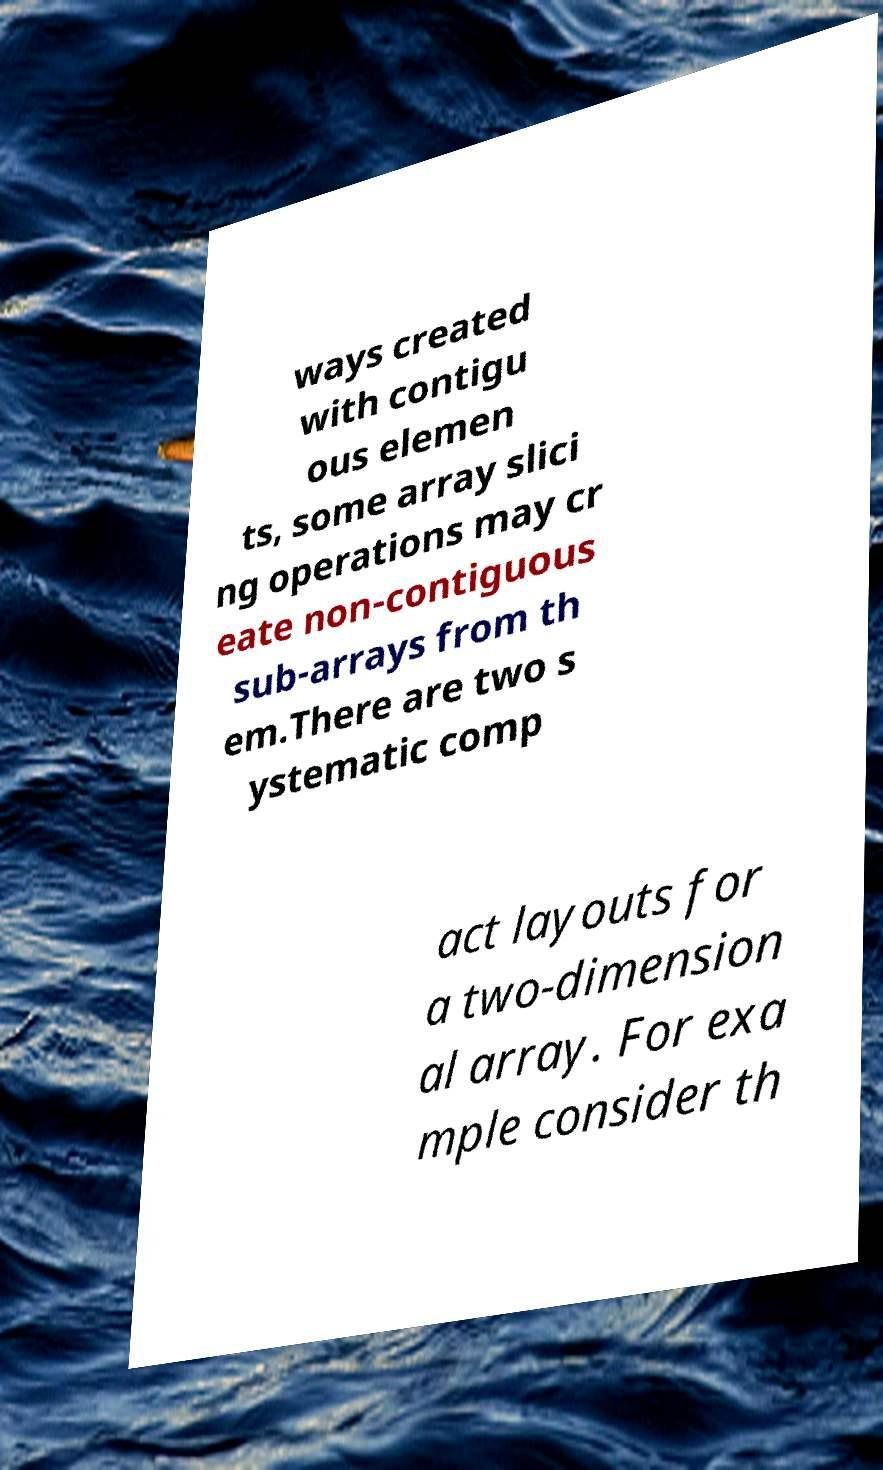There's text embedded in this image that I need extracted. Can you transcribe it verbatim? ways created with contigu ous elemen ts, some array slici ng operations may cr eate non-contiguous sub-arrays from th em.There are two s ystematic comp act layouts for a two-dimension al array. For exa mple consider th 